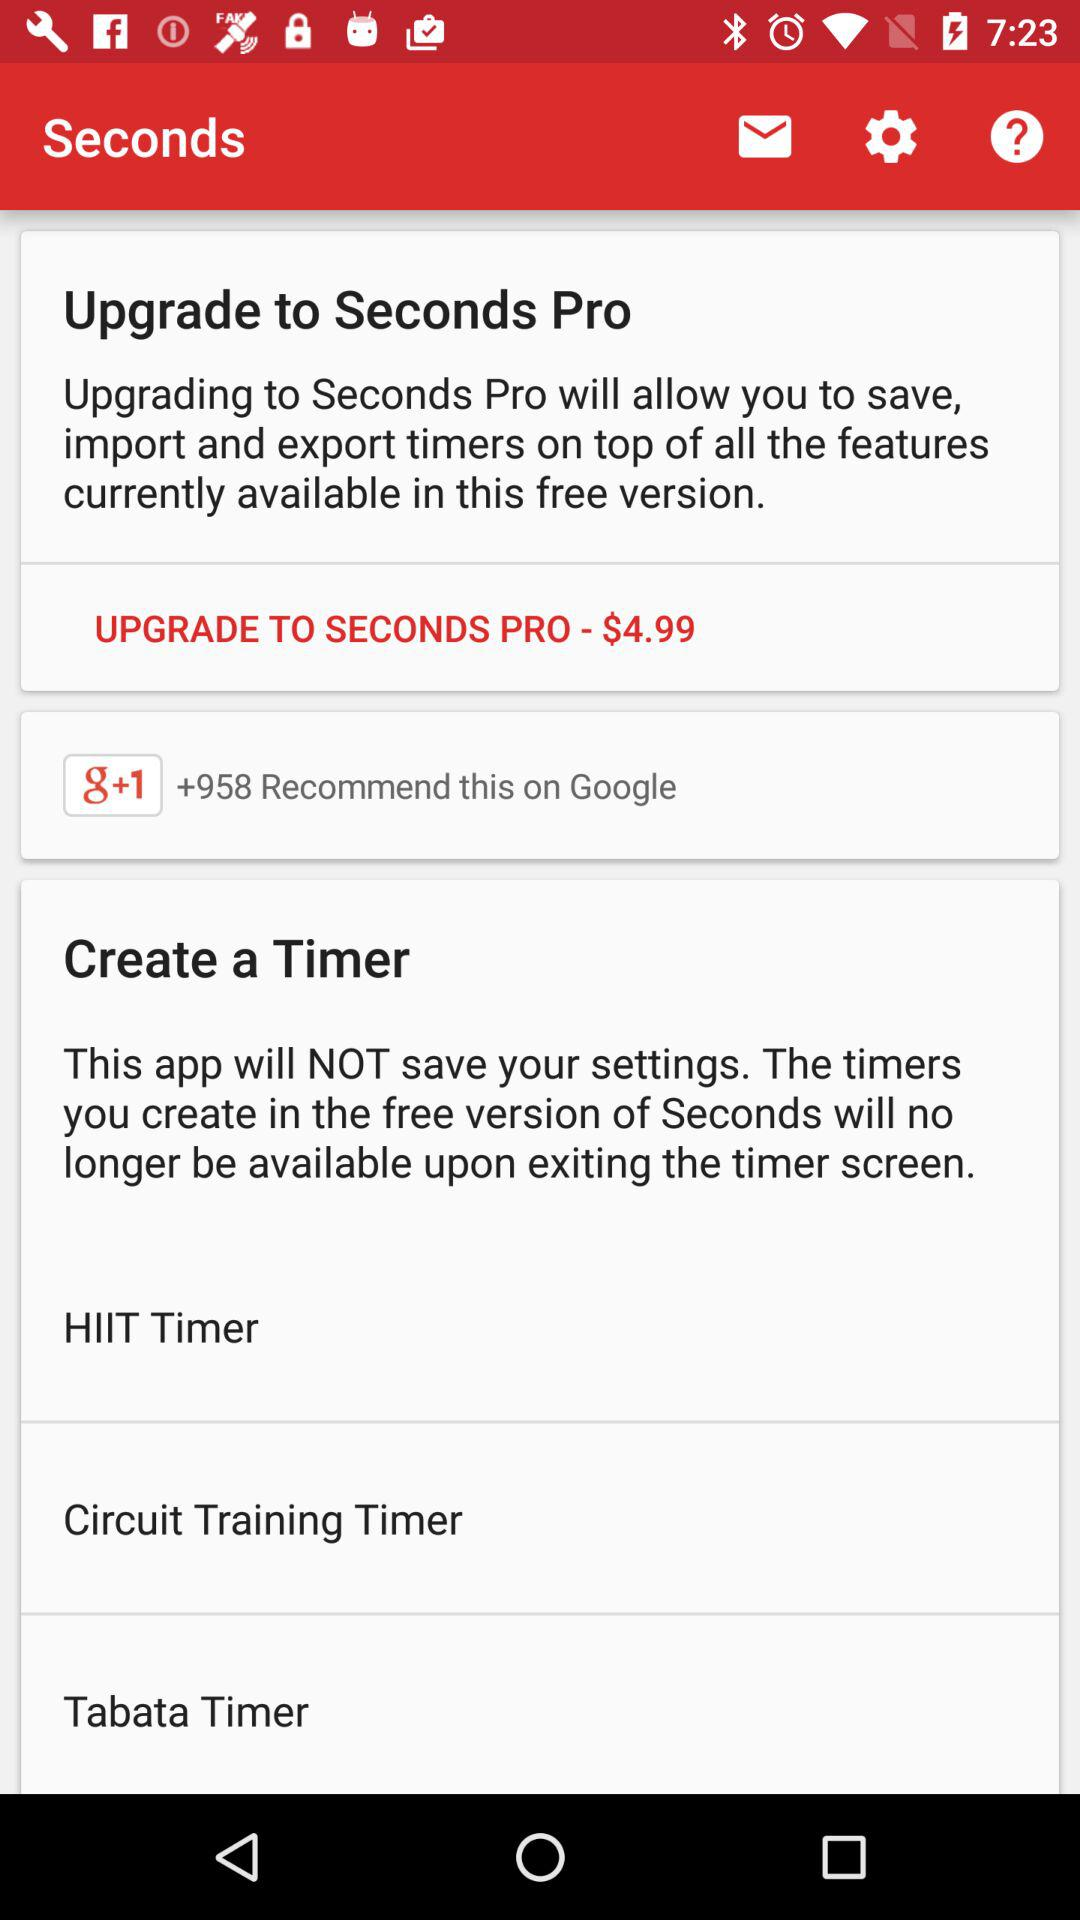How many people recommended this on "Facebook"?
When the provided information is insufficient, respond with <no answer>. <no answer> 